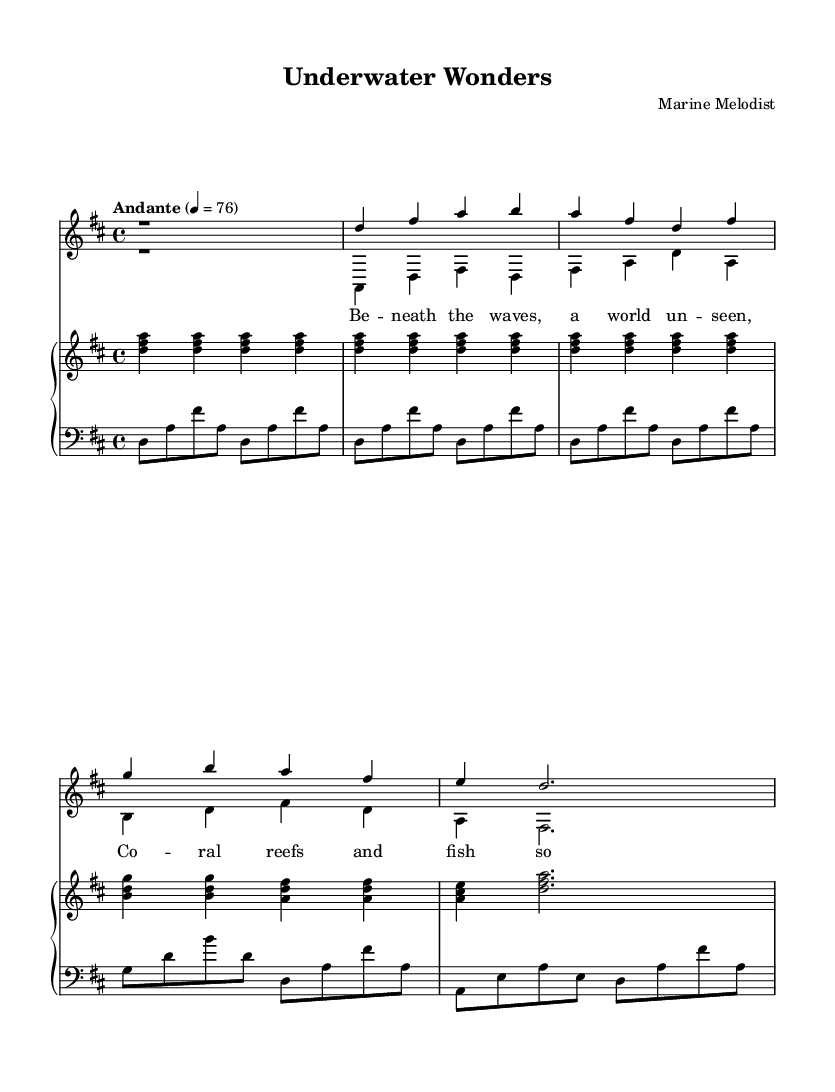What is the key signature of this music? The key signature indicated in the staff shows two sharps, which correspond to the notes F# and C# in the key of D major.
Answer: D major What is the time signature of this music? The time signature in the sheet music is represented by "4/4," which signifies that there are four beats in each measure and the quarter note gets one beat.
Answer: 4/4 What is the tempo marking for this piece? The tempo marking appears above the staff as "Andante," which is a common term used to indicate a moderate pace, typically around 76 beats per minute.
Answer: Andante How many measures are present in the soprano part? By visually counting the distinct groupings of notes and rests in the soprano part, we find that there are a total of four measures indicated.
Answer: 4 What is the last note in the baritone part? The last note in the written baritone part is a half note (d) which appears following the previous rhythmic patterns laid out in the measures.
Answer: D What is the thematic focus of the lyrics? The lyrics describe underwater exploration, referencing "coral reefs" and "a world unseen," which highlights the theme of marine discovery and fascination with ocean life.
Answer: Underwater exploration What is the role of the piano accompaniment in this piece? The piano accompaniment serves to provide harmonic support and texture to the vocal lines, reinforcing the romantic quality of the music while allowing the voices to be the primary focus.
Answer: Harmonic support 